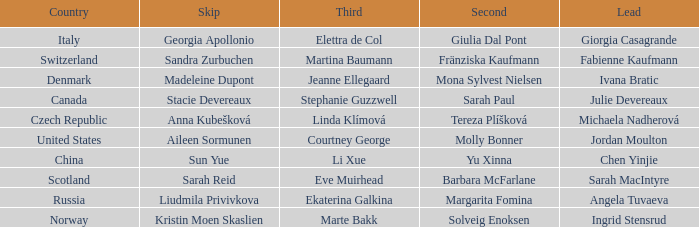What skip has martina baumann as the third? Sandra Zurbuchen. 